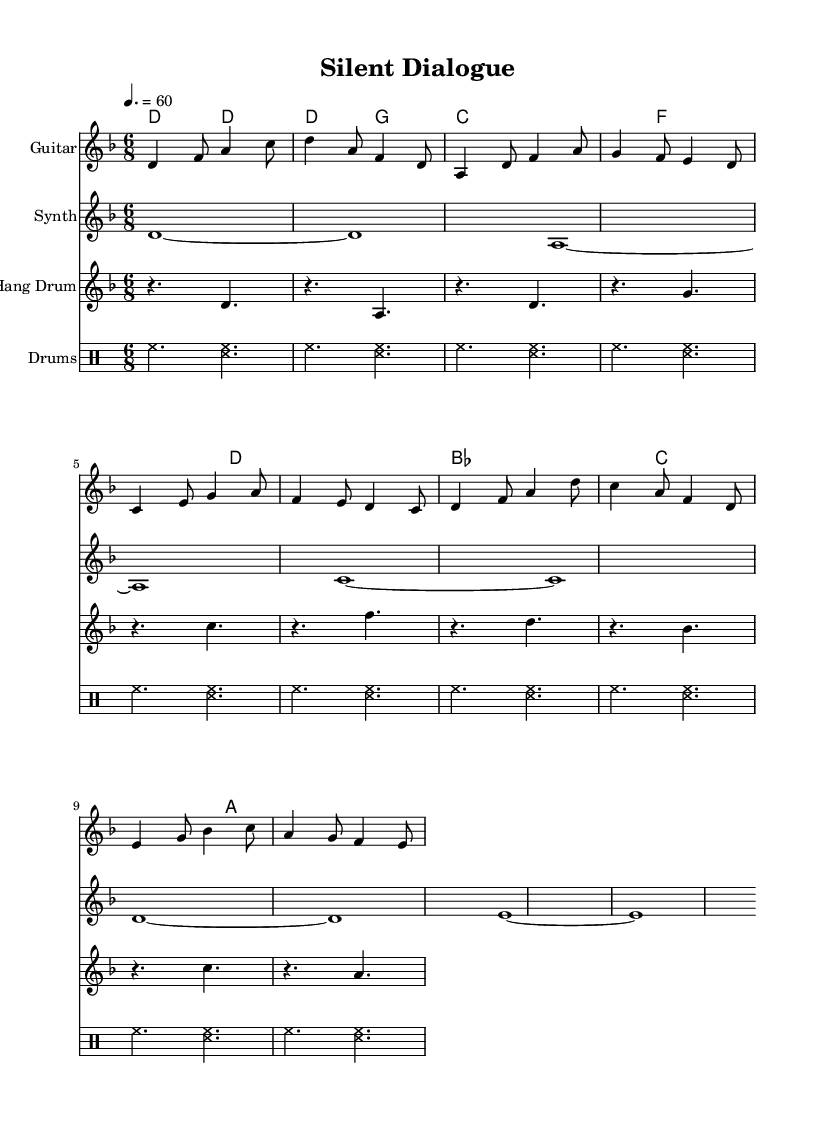What is the key signature of this music? The key signature is D minor, which has one flat, represented by the key signature indicating "B♭."
Answer: D minor What is the time signature of the piece? The time signature is 6/8, which shows that there are six eighth-note beats in each measure.
Answer: 6/8 What is the tempo marking of the music? The tempo marking is 60 beats per minute, indicated by the notation "4. = 60."
Answer: 60 How many measures are in the guitar part? The guitar part contains 10 measures, as counted visually on the sheet music.
Answer: 10 What type of rhythm pattern is used in the hang drum section? The hang drum section features a simplified rhythm pattern that consists primarily of whole notes and rests, creating a direct, steady feel.
Answer: Whole notes Which instrument carries the melodic content in the chorus? The guitar carries the melodic content in the chorus, with distinct notes and phrasing that stand out in that part.
Answer: Guitar What chord is played at the end of the piece in the chord progression? The chord played at the end is A minor, marking a resolution and closure in the harmonic progression.
Answer: A minor 